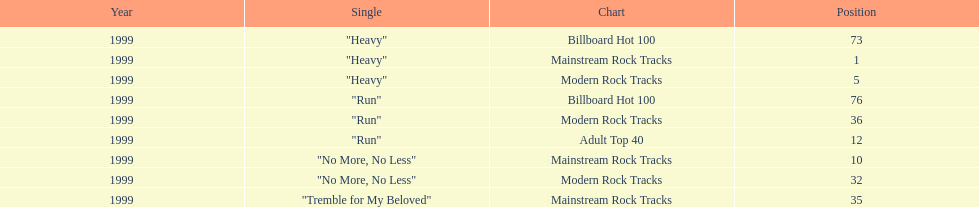How many different charts did "run" make? 3. 